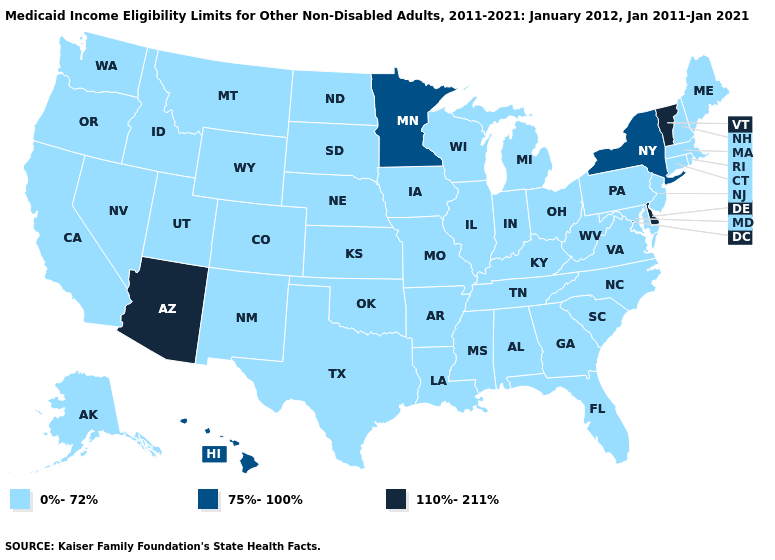What is the highest value in the USA?
Keep it brief. 110%-211%. Does New York have the lowest value in the Northeast?
Write a very short answer. No. Among the states that border Michigan , which have the lowest value?
Short answer required. Indiana, Ohio, Wisconsin. Among the states that border Washington , which have the highest value?
Write a very short answer. Idaho, Oregon. What is the value of Indiana?
Give a very brief answer. 0%-72%. Does Virginia have a higher value than Colorado?
Be succinct. No. What is the value of Kansas?
Concise answer only. 0%-72%. Among the states that border Vermont , which have the lowest value?
Give a very brief answer. Massachusetts, New Hampshire. Name the states that have a value in the range 0%-72%?
Be succinct. Alabama, Alaska, Arkansas, California, Colorado, Connecticut, Florida, Georgia, Idaho, Illinois, Indiana, Iowa, Kansas, Kentucky, Louisiana, Maine, Maryland, Massachusetts, Michigan, Mississippi, Missouri, Montana, Nebraska, Nevada, New Hampshire, New Jersey, New Mexico, North Carolina, North Dakota, Ohio, Oklahoma, Oregon, Pennsylvania, Rhode Island, South Carolina, South Dakota, Tennessee, Texas, Utah, Virginia, Washington, West Virginia, Wisconsin, Wyoming. What is the value of West Virginia?
Short answer required. 0%-72%. Name the states that have a value in the range 110%-211%?
Concise answer only. Arizona, Delaware, Vermont. How many symbols are there in the legend?
Keep it brief. 3. How many symbols are there in the legend?
Be succinct. 3. Name the states that have a value in the range 0%-72%?
Be succinct. Alabama, Alaska, Arkansas, California, Colorado, Connecticut, Florida, Georgia, Idaho, Illinois, Indiana, Iowa, Kansas, Kentucky, Louisiana, Maine, Maryland, Massachusetts, Michigan, Mississippi, Missouri, Montana, Nebraska, Nevada, New Hampshire, New Jersey, New Mexico, North Carolina, North Dakota, Ohio, Oklahoma, Oregon, Pennsylvania, Rhode Island, South Carolina, South Dakota, Tennessee, Texas, Utah, Virginia, Washington, West Virginia, Wisconsin, Wyoming. Which states have the highest value in the USA?
Write a very short answer. Arizona, Delaware, Vermont. 